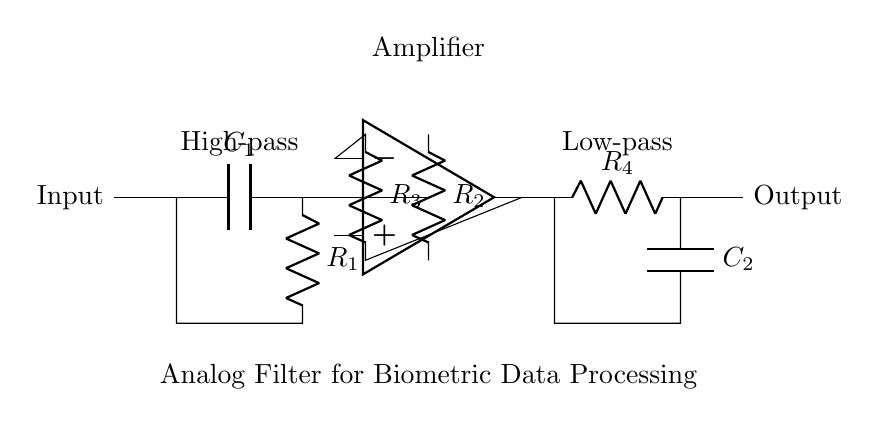What type of filter is implemented at the input? The circuit includes a high-pass filter at the input, indicated by the capacitor and resistor connected in series. High-pass filters allow signals higher than a certain cutoff frequency to pass through while attenuating lower frequencies.
Answer: High-pass What is the role of the op-amp in this circuit? The operational amplifier amplifies the signal received after passing through the high-pass filter. Its configuration within the circuit suggests that it enhances the amplitude of the processed signal before it goes through the low-pass filter.
Answer: Amplification How many resistors are present in this circuit? There are four resistors identified as R1, R2, R3, and R4, and they are placed in different sections of the circuit: the high-pass filter, the amplifier, and the low-pass filter.
Answer: Four What components make up the low-pass filter? The low-pass filter consists of resistor R4 and capacitor C2 arranged in parallel, which allows signals below a certain cutoff frequency to pass while attenuating higher frequencies.
Answer: Resistor and capacitor What does the label 'Analog Filter for Biometric Data Processing' indicate? The label signifies that this specific circuit is designed for processing biological signals, such as heart rate or activity data, in devices like wearable fitness trackers, emphasizing its application area.
Answer: Biometric data processing What is the function of capacitor C1 in the circuit? Capacitor C1, located at the input, functions to block DC components of the incoming signal while allowing AC components above a certain frequency to pass through, crucial for isolating AC signals of interest.
Answer: Blocking DC What can be inferred about the output of this circuit? The output indicates that the processed signal has gone through both filtering stages (high-pass and low-pass) and amplification, suggesting the final output should be a refined version of the input signal, suitable for further processing or display.
Answer: Refined signal 